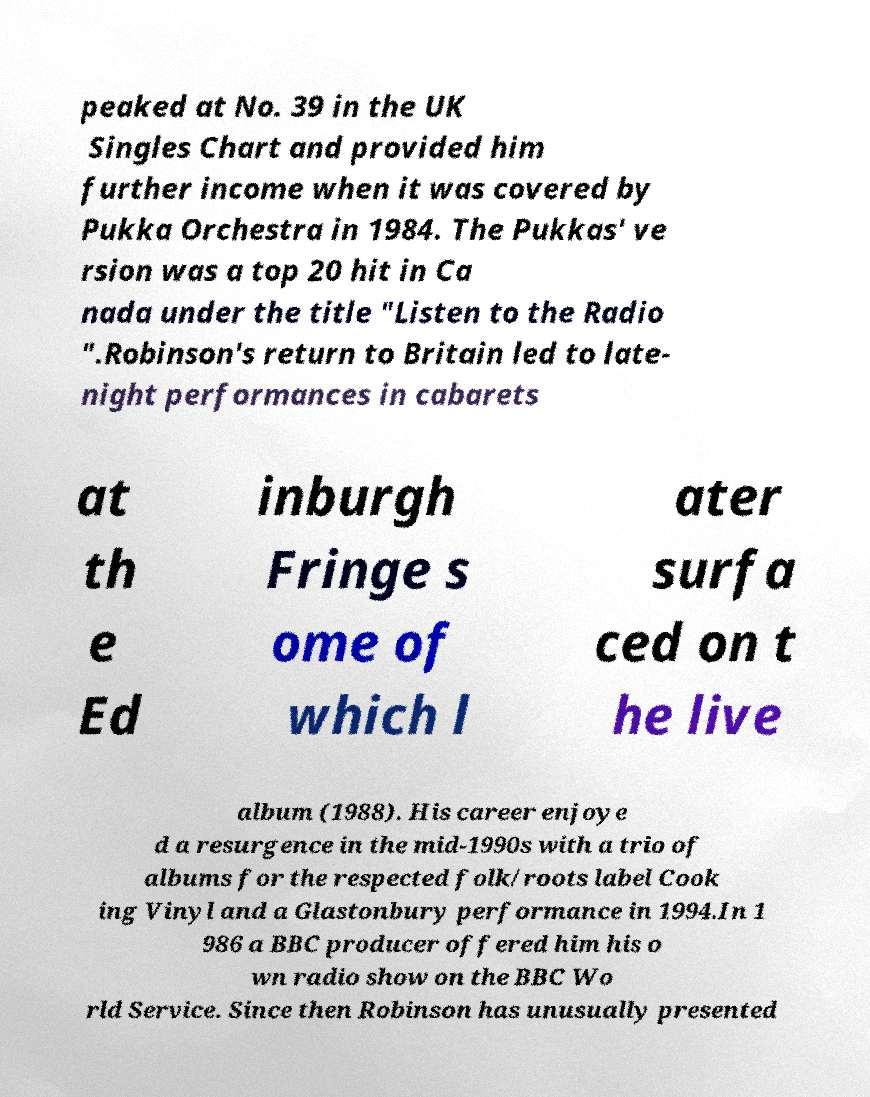Could you extract and type out the text from this image? peaked at No. 39 in the UK Singles Chart and provided him further income when it was covered by Pukka Orchestra in 1984. The Pukkas' ve rsion was a top 20 hit in Ca nada under the title "Listen to the Radio ".Robinson's return to Britain led to late- night performances in cabarets at th e Ed inburgh Fringe s ome of which l ater surfa ced on t he live album (1988). His career enjoye d a resurgence in the mid-1990s with a trio of albums for the respected folk/roots label Cook ing Vinyl and a Glastonbury performance in 1994.In 1 986 a BBC producer offered him his o wn radio show on the BBC Wo rld Service. Since then Robinson has unusually presented 